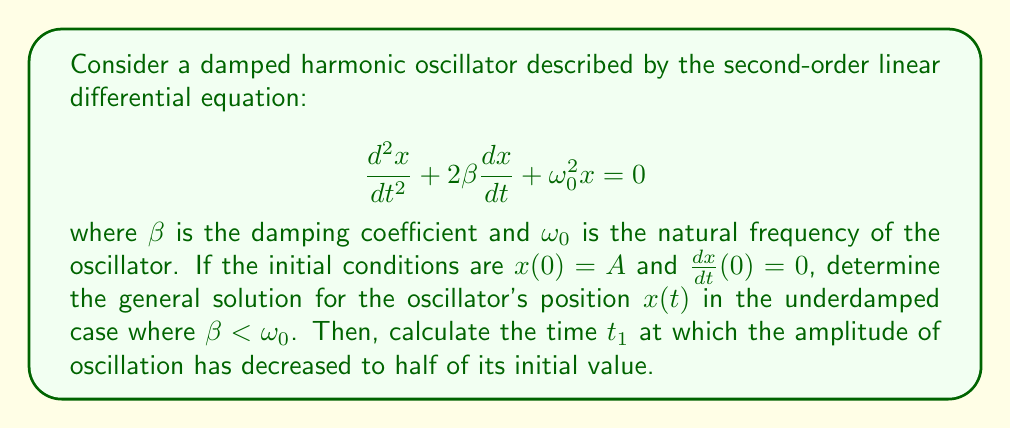Could you help me with this problem? To solve this problem, we'll follow these steps:

1) First, we need to find the general solution for the underdamped case.

2) The characteristic equation for this differential equation is:
   $$r^2 + 2\beta r + \omega_0^2 = 0$$

3) The roots of this equation are:
   $$r = -\beta \pm \sqrt{\beta^2 - \omega_0^2}$$

4) In the underdamped case ($\beta < \omega_0$), these roots are complex:
   $$r = -\beta \pm i\omega_d$$
   where $\omega_d = \sqrt{\omega_0^2 - \beta^2}$ is the damped frequency.

5) The general solution for the underdamped case is:
   $$x(t) = e^{-\beta t}(C_1 \cos(\omega_d t) + C_2 \sin(\omega_d t))$$

6) Using the initial conditions, we can determine $C_1$ and $C_2$:
   $x(0) = A$ implies $C_1 = A$
   $\frac{dx}{dt}(0) = 0$ implies $C_2 = \frac{\beta A}{\omega_d}$

7) Therefore, the solution satisfying the initial conditions is:
   $$x(t) = Ae^{-\beta t}\left(\cos(\omega_d t) + \frac{\beta}{\omega_d}\sin(\omega_d t)\right)$$

8) The amplitude of this oscillation is given by:
   $$A(t) = Ae^{-\beta t}$$

9) To find $t_1$, we need to solve:
   $$\frac{A(t_1)}{A(0)} = \frac{1}{2}$$

10) This gives us:
    $$e^{-\beta t_1} = \frac{1}{2}$$

11) Taking the natural logarithm of both sides:
    $$-\beta t_1 = \ln(\frac{1}{2}) = -\ln(2)$$

12) Solving for $t_1$:
    $$t_1 = \frac{\ln(2)}{\beta}$$

This gives us the time at which the amplitude has decreased to half its initial value.
Answer: The general solution for the oscillator's position is:
$$x(t) = Ae^{-\beta t}\left(\cos(\omega_d t) + \frac{\beta}{\omega_d}\sin(\omega_d t)\right)$$
where $\omega_d = \sqrt{\omega_0^2 - \beta^2}$.

The time $t_1$ at which the amplitude has decreased to half its initial value is:
$$t_1 = \frac{\ln(2)}{\beta}$$ 